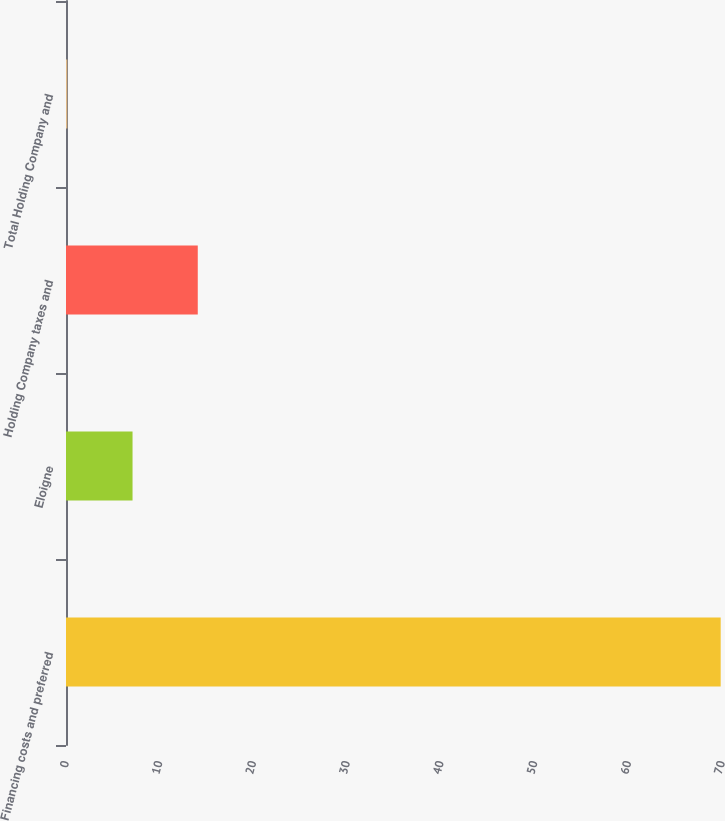Convert chart. <chart><loc_0><loc_0><loc_500><loc_500><bar_chart><fcel>Financing costs and preferred<fcel>Eloigne<fcel>Holding Company taxes and<fcel>Total Holding Company and<nl><fcel>69.86<fcel>7.1<fcel>14.06<fcel>0.14<nl></chart> 